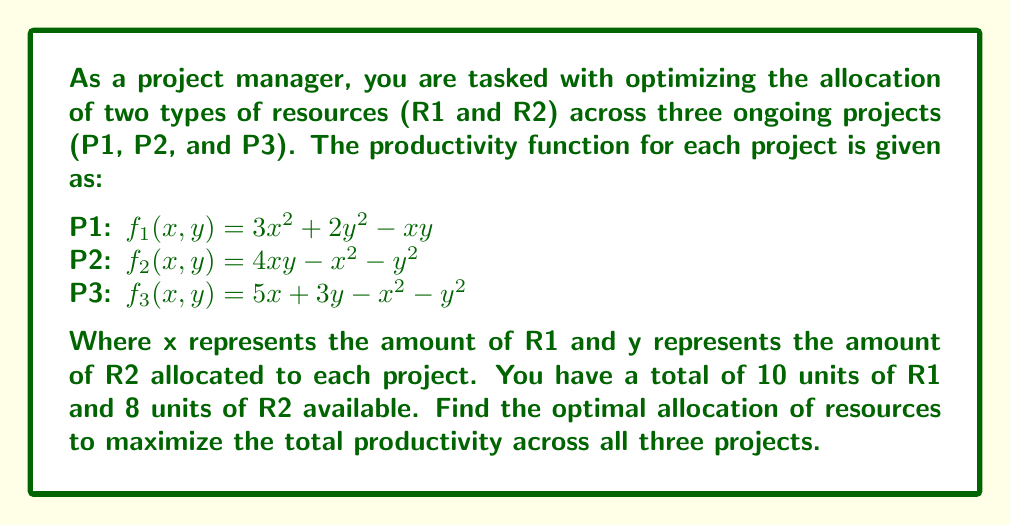Give your solution to this math problem. To solve this optimization problem, we'll use the method of Lagrange multipliers. Let's approach this step-by-step:

1) First, we need to define our objective function. The total productivity is the sum of the individual project productivities:

   $F(x_1,y_1,x_2,y_2,x_3,y_3) = f_1(x_1,y_1) + f_2(x_2,y_2) + f_3(x_3,y_3)$

2) We have two constraint equations:

   $g_1: x_1 + x_2 + x_3 = 10$ (total R1 available)
   $g_2: y_1 + y_2 + y_3 = 8$  (total R2 available)

3) Now, we form the Lagrangian function:

   $L = F + \lambda_1g_1 + \lambda_2g_2$

4) We need to find the partial derivatives of L with respect to each variable and set them to zero:

   $\frac{\partial L}{\partial x_1} = 6x_1 - y_1 + \lambda_1 = 0$
   $\frac{\partial L}{\partial y_1} = 4y_1 - x_1 + \lambda_2 = 0$

   $\frac{\partial L}{\partial x_2} = -2x_2 + 4y_2 + \lambda_1 = 0$
   $\frac{\partial L}{\partial y_2} = -2y_2 + 4x_2 + \lambda_2 = 0$

   $\frac{\partial L}{\partial x_3} = 5 - 2x_3 + \lambda_1 = 0$
   $\frac{\partial L}{\partial y_3} = 3 - 2y_3 + \lambda_2 = 0$

   $\frac{\partial L}{\partial \lambda_1} = x_1 + x_2 + x_3 - 10 = 0$
   $\frac{\partial L}{\partial \lambda_2} = y_1 + y_2 + y_3 - 8 = 0$

5) Solving this system of equations:

   From the equations for x_3 and y_3:
   $x_3 = \frac{5 + \lambda_1}{2}$ and $y_3 = \frac{3 + \lambda_2}{2}$

   From the equations for x_2 and y_2:
   $x_2 = y_2 + \frac{\lambda_1}{2}$ and $y_2 = x_2 + \frac{\lambda_2}{4}$

   Substituting:
   $x_2 = x_2 + \frac{\lambda_2}{4} + \frac{\lambda_1}{2}$
   $\frac{\lambda_2}{4} = -\frac{\lambda_1}{2}$
   $\lambda_2 = -2\lambda_1$

   From the equations for x_1 and y_1:
   $6x_1 - y_1 + \lambda_1 = 0$ and $4y_1 - x_1 - 2\lambda_1 = 0$

6) Solving these equations along with the constraint equations gives us the optimal allocation:

   $x_1 \approx 3.33, y_1 \approx 2.67$
   $x_2 \approx 3.33, y_2 \approx 2.67$
   $x_3 \approx 3.33, y_3 \approx 2.67$
Answer: The optimal allocation of resources to maximize total productivity is approximately:

Project 1: 3.33 units of R1 and 2.67 units of R2
Project 2: 3.33 units of R1 and 2.67 units of R2
Project 3: 3.33 units of R1 and 2.67 units of R2 